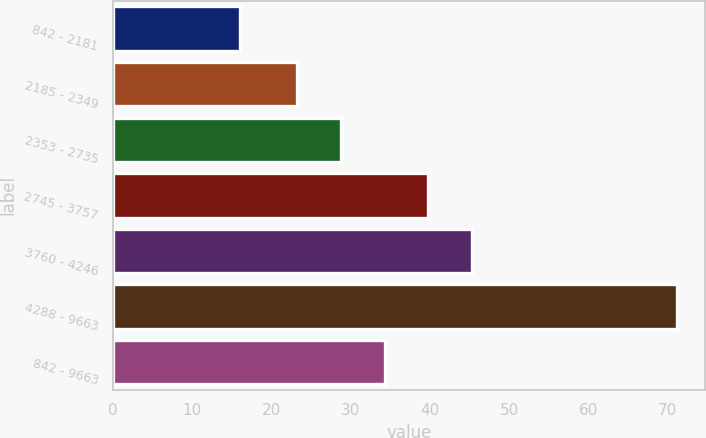Convert chart. <chart><loc_0><loc_0><loc_500><loc_500><bar_chart><fcel>842 - 2181<fcel>2185 - 2349<fcel>2353 - 2735<fcel>2745 - 3757<fcel>3760 - 4246<fcel>4288 - 9663<fcel>842 - 9663<nl><fcel>16.03<fcel>23.27<fcel>28.78<fcel>39.8<fcel>45.31<fcel>71.16<fcel>34.29<nl></chart> 